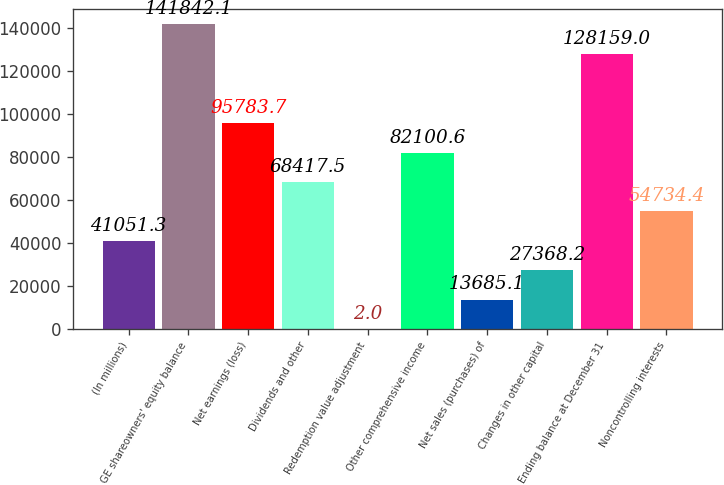<chart> <loc_0><loc_0><loc_500><loc_500><bar_chart><fcel>(In millions)<fcel>GE shareowners' equity balance<fcel>Net earnings (loss)<fcel>Dividends and other<fcel>Redemption value adjustment<fcel>Other comprehensive income<fcel>Net sales (purchases) of<fcel>Changes in other capital<fcel>Ending balance at December 31<fcel>Noncontrolling interests<nl><fcel>41051.3<fcel>141842<fcel>95783.7<fcel>68417.5<fcel>2<fcel>82100.6<fcel>13685.1<fcel>27368.2<fcel>128159<fcel>54734.4<nl></chart> 